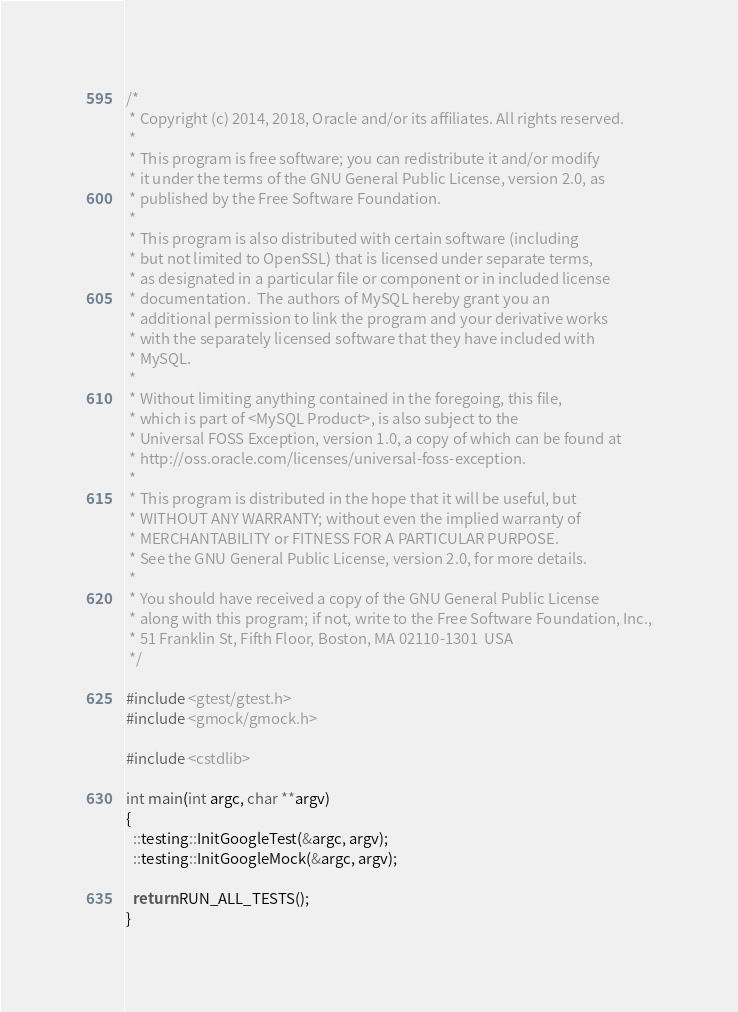<code> <loc_0><loc_0><loc_500><loc_500><_C++_>/*
 * Copyright (c) 2014, 2018, Oracle and/or its affiliates. All rights reserved.
 *
 * This program is free software; you can redistribute it and/or modify
 * it under the terms of the GNU General Public License, version 2.0, as
 * published by the Free Software Foundation.
 *
 * This program is also distributed with certain software (including
 * but not limited to OpenSSL) that is licensed under separate terms,
 * as designated in a particular file or component or in included license
 * documentation.  The authors of MySQL hereby grant you an
 * additional permission to link the program and your derivative works
 * with the separately licensed software that they have included with
 * MySQL.
 *
 * Without limiting anything contained in the foregoing, this file,
 * which is part of <MySQL Product>, is also subject to the
 * Universal FOSS Exception, version 1.0, a copy of which can be found at
 * http://oss.oracle.com/licenses/universal-foss-exception.
 *
 * This program is distributed in the hope that it will be useful, but
 * WITHOUT ANY WARRANTY; without even the implied warranty of
 * MERCHANTABILITY or FITNESS FOR A PARTICULAR PURPOSE.
 * See the GNU General Public License, version 2.0, for more details.
 *
 * You should have received a copy of the GNU General Public License
 * along with this program; if not, write to the Free Software Foundation, Inc.,
 * 51 Franklin St, Fifth Floor, Boston, MA 02110-1301  USA
 */

#include <gtest/gtest.h>
#include <gmock/gmock.h>

#include <cstdlib>

int main(int argc, char **argv)
{
  ::testing::InitGoogleTest(&argc, argv);
  ::testing::InitGoogleMock(&argc, argv);

  return RUN_ALL_TESTS();
}
</code> 